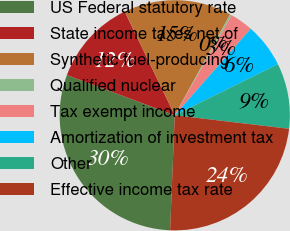Convert chart to OTSL. <chart><loc_0><loc_0><loc_500><loc_500><pie_chart><fcel>US Federal statutory rate<fcel>State income taxes net of<fcel>Synthetic fuel-producing<fcel>Qualified nuclear<fcel>Tax exempt income<fcel>Amortization of investment tax<fcel>Other<fcel>Effective income tax rate<nl><fcel>30.03%<fcel>12.17%<fcel>15.14%<fcel>0.26%<fcel>3.23%<fcel>6.21%<fcel>9.19%<fcel>23.77%<nl></chart> 